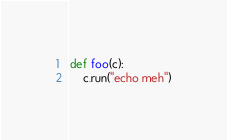<code> <loc_0><loc_0><loc_500><loc_500><_Python_>def foo(c):
    c.run("echo meh")
</code> 